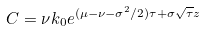<formula> <loc_0><loc_0><loc_500><loc_500>C = \nu k _ { 0 } e ^ { ( \mu - \nu - \sigma ^ { 2 } / 2 ) \tau + \sigma \sqrt { \tau } z }</formula> 